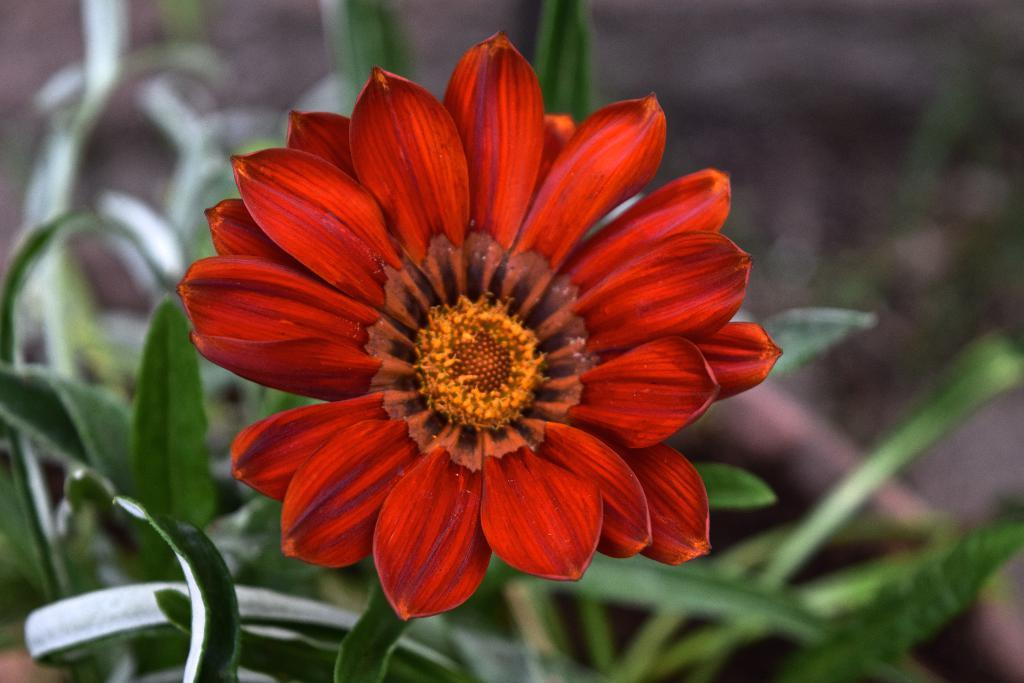What is the main subject in the middle of the image? There is a flower in the middle of the image. Are there any other plants visible in the image? Yes, there are a few plants in the image. What type of soup is being served in the image? There is no soup present in the image; it features a flower and a few plants. How does the flower start its journey in the image? The flower does not start a journey in the image; it is stationary in the middle of the image. 